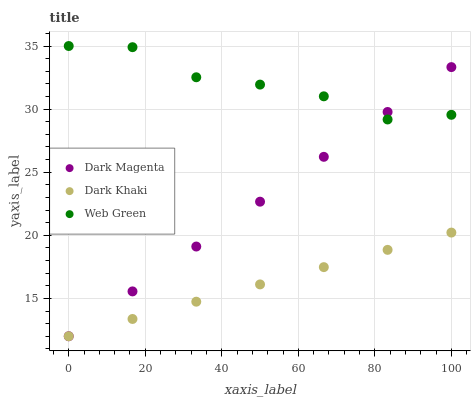Does Dark Khaki have the minimum area under the curve?
Answer yes or no. Yes. Does Web Green have the maximum area under the curve?
Answer yes or no. Yes. Does Dark Magenta have the minimum area under the curve?
Answer yes or no. No. Does Dark Magenta have the maximum area under the curve?
Answer yes or no. No. Is Dark Khaki the smoothest?
Answer yes or no. Yes. Is Web Green the roughest?
Answer yes or no. Yes. Is Dark Magenta the smoothest?
Answer yes or no. No. Is Dark Magenta the roughest?
Answer yes or no. No. Does Dark Khaki have the lowest value?
Answer yes or no. Yes. Does Web Green have the lowest value?
Answer yes or no. No. Does Web Green have the highest value?
Answer yes or no. Yes. Does Dark Magenta have the highest value?
Answer yes or no. No. Is Dark Khaki less than Web Green?
Answer yes or no. Yes. Is Web Green greater than Dark Khaki?
Answer yes or no. Yes. Does Web Green intersect Dark Magenta?
Answer yes or no. Yes. Is Web Green less than Dark Magenta?
Answer yes or no. No. Is Web Green greater than Dark Magenta?
Answer yes or no. No. Does Dark Khaki intersect Web Green?
Answer yes or no. No. 